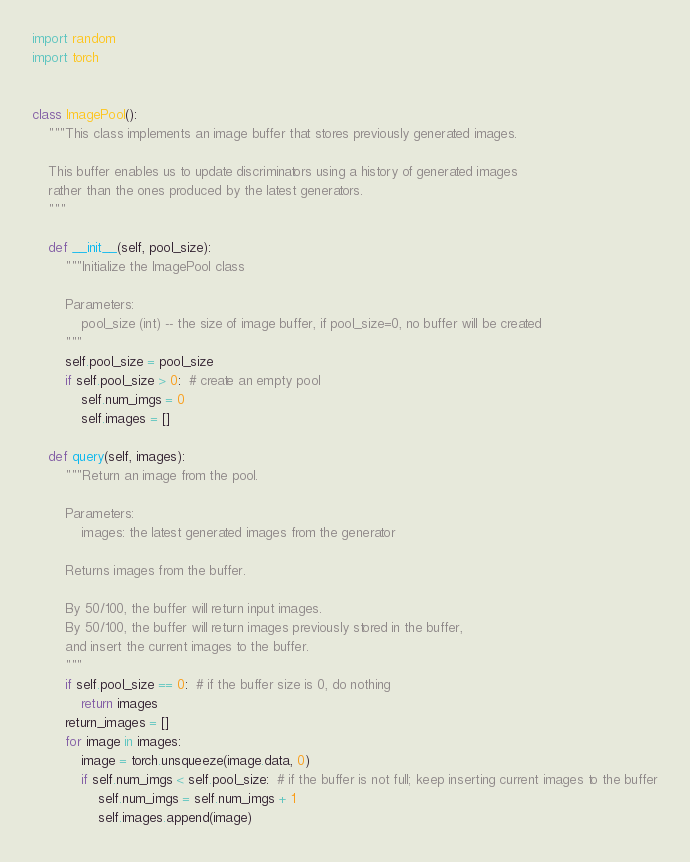<code> <loc_0><loc_0><loc_500><loc_500><_Python_>import random
import torch


class ImagePool():
    """This class implements an image buffer that stores previously generated images.

    This buffer enables us to update discriminators using a history of generated images
    rather than the ones produced by the latest generators.
    """

    def __init__(self, pool_size):
        """Initialize the ImagePool class

        Parameters:
            pool_size (int) -- the size of image buffer, if pool_size=0, no buffer will be created
        """
        self.pool_size = pool_size
        if self.pool_size > 0:  # create an empty pool
            self.num_imgs = 0
            self.images = []

    def query(self, images):
        """Return an image from the pool.

        Parameters:
            images: the latest generated images from the generator

        Returns images from the buffer.

        By 50/100, the buffer will return input images.
        By 50/100, the buffer will return images previously stored in the buffer,
        and insert the current images to the buffer.
        """
        if self.pool_size == 0:  # if the buffer size is 0, do nothing
            return images
        return_images = []
        for image in images:
            image = torch.unsqueeze(image.data, 0)
            if self.num_imgs < self.pool_size:  # if the buffer is not full; keep inserting current images to the buffer
                self.num_imgs = self.num_imgs + 1
                self.images.append(image)</code> 